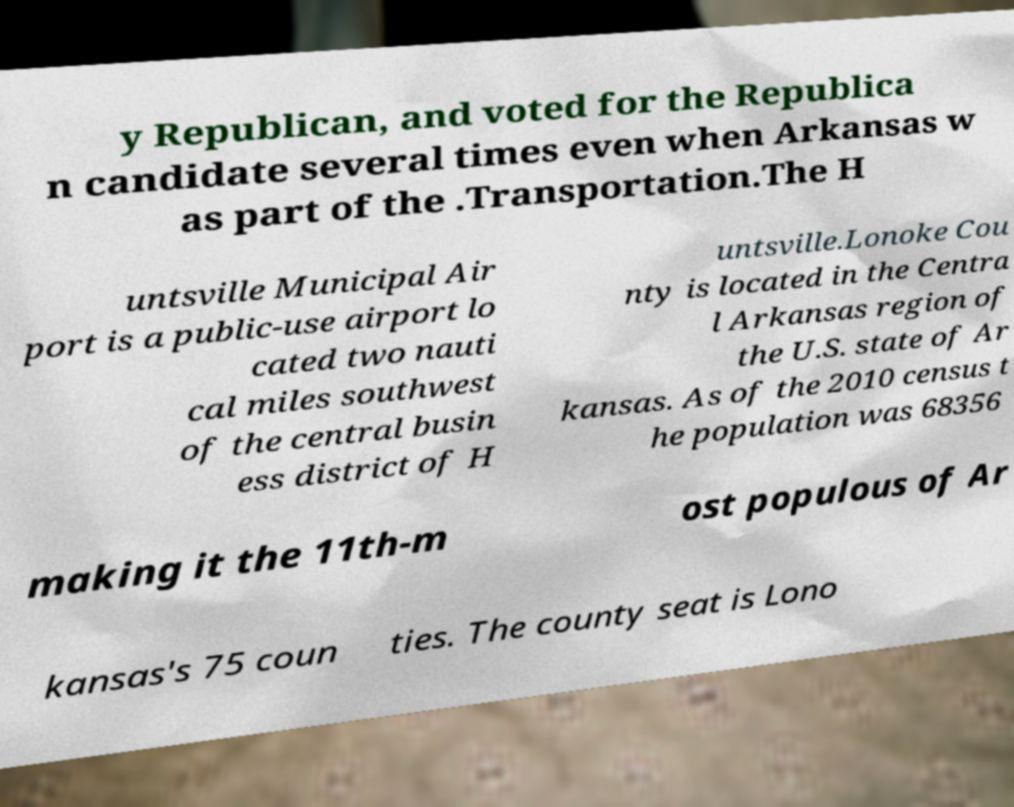I need the written content from this picture converted into text. Can you do that? y Republican, and voted for the Republica n candidate several times even when Arkansas w as part of the .Transportation.The H untsville Municipal Air port is a public-use airport lo cated two nauti cal miles southwest of the central busin ess district of H untsville.Lonoke Cou nty is located in the Centra l Arkansas region of the U.S. state of Ar kansas. As of the 2010 census t he population was 68356 making it the 11th-m ost populous of Ar kansas's 75 coun ties. The county seat is Lono 